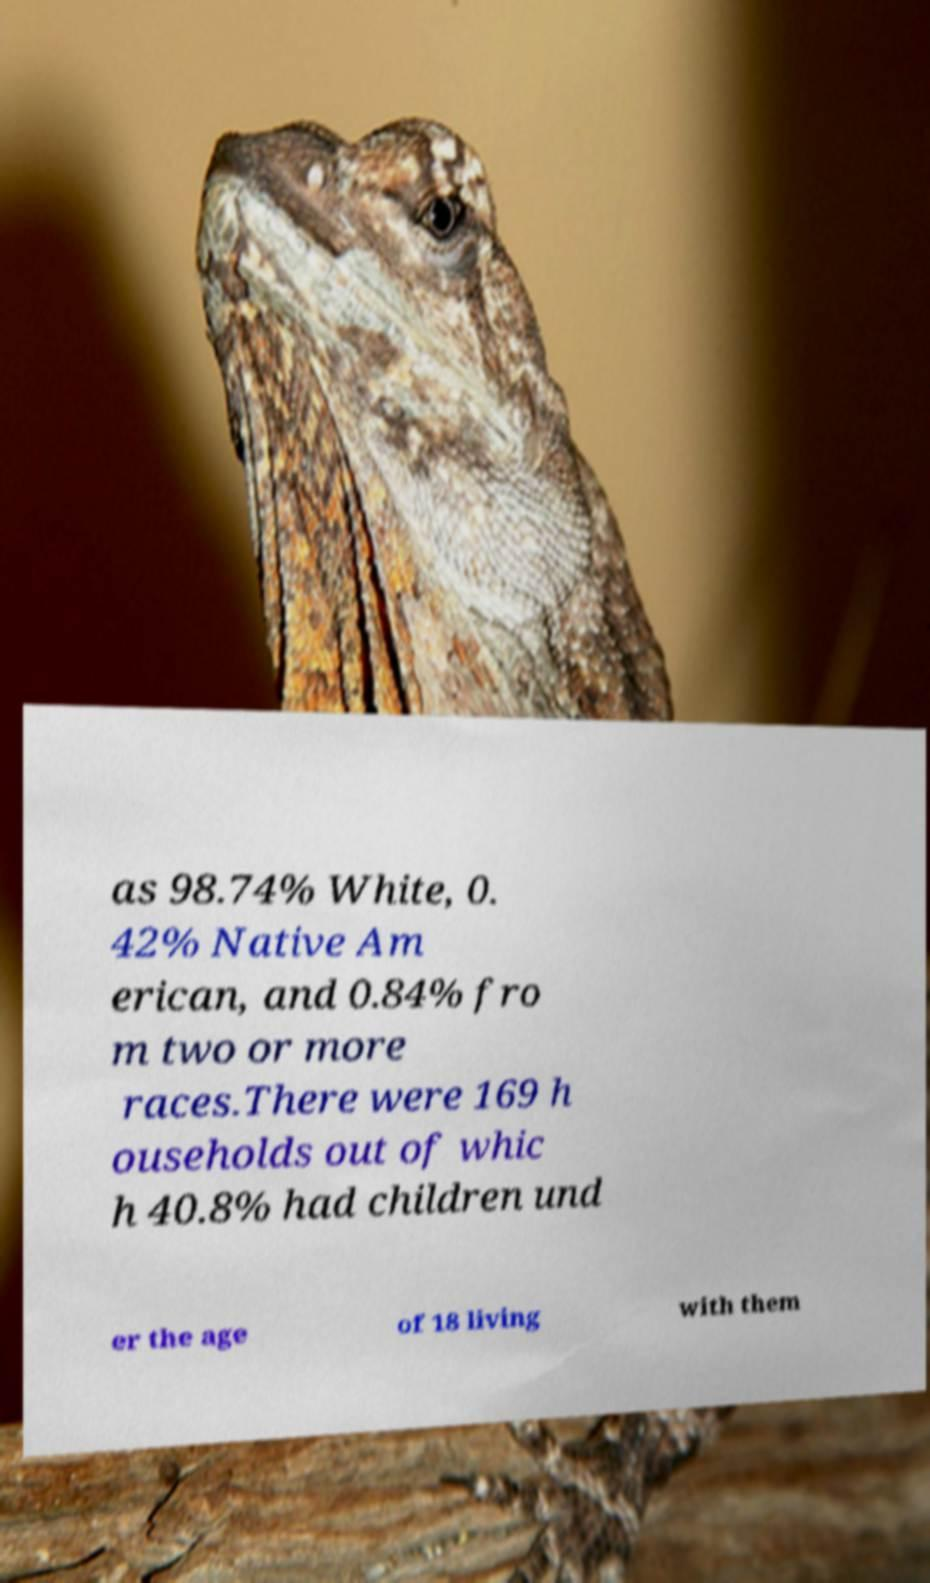What messages or text are displayed in this image? I need them in a readable, typed format. as 98.74% White, 0. 42% Native Am erican, and 0.84% fro m two or more races.There were 169 h ouseholds out of whic h 40.8% had children und er the age of 18 living with them 